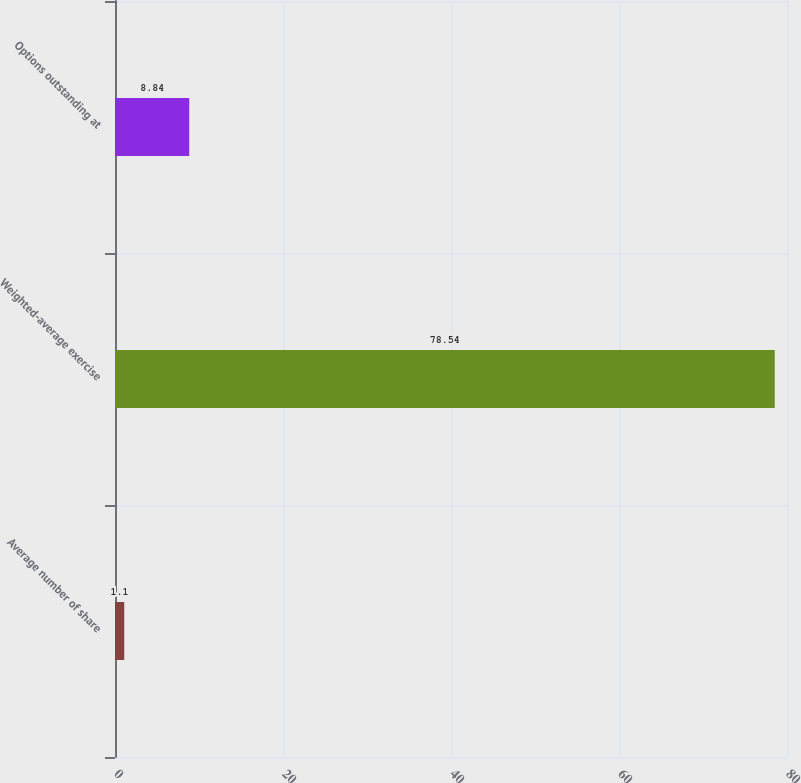Convert chart. <chart><loc_0><loc_0><loc_500><loc_500><bar_chart><fcel>Average number of share<fcel>Weighted-average exercise<fcel>Options outstanding at<nl><fcel>1.1<fcel>78.54<fcel>8.84<nl></chart> 